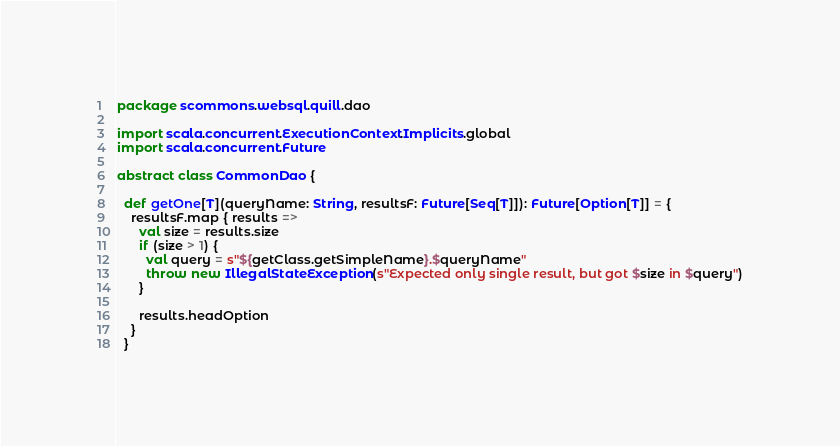Convert code to text. <code><loc_0><loc_0><loc_500><loc_500><_Scala_>package scommons.websql.quill.dao

import scala.concurrent.ExecutionContext.Implicits.global
import scala.concurrent.Future

abstract class CommonDao {

  def getOne[T](queryName: String, resultsF: Future[Seq[T]]): Future[Option[T]] = {
    resultsF.map { results =>
      val size = results.size
      if (size > 1) {
        val query = s"${getClass.getSimpleName}.$queryName"
        throw new IllegalStateException(s"Expected only single result, but got $size in $query")
      }

      results.headOption
    }
  }
</code> 